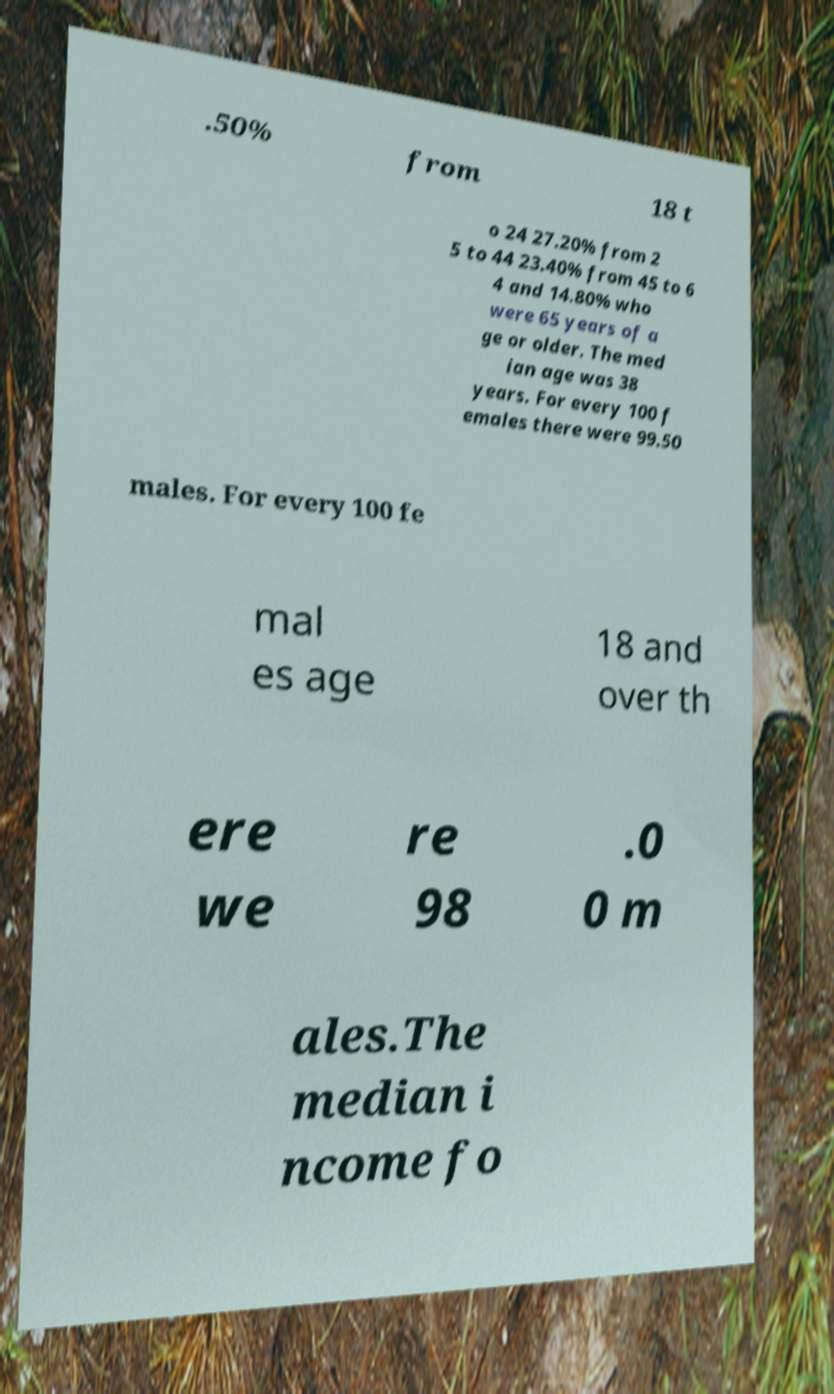There's text embedded in this image that I need extracted. Can you transcribe it verbatim? .50% from 18 t o 24 27.20% from 2 5 to 44 23.40% from 45 to 6 4 and 14.80% who were 65 years of a ge or older. The med ian age was 38 years. For every 100 f emales there were 99.50 males. For every 100 fe mal es age 18 and over th ere we re 98 .0 0 m ales.The median i ncome fo 